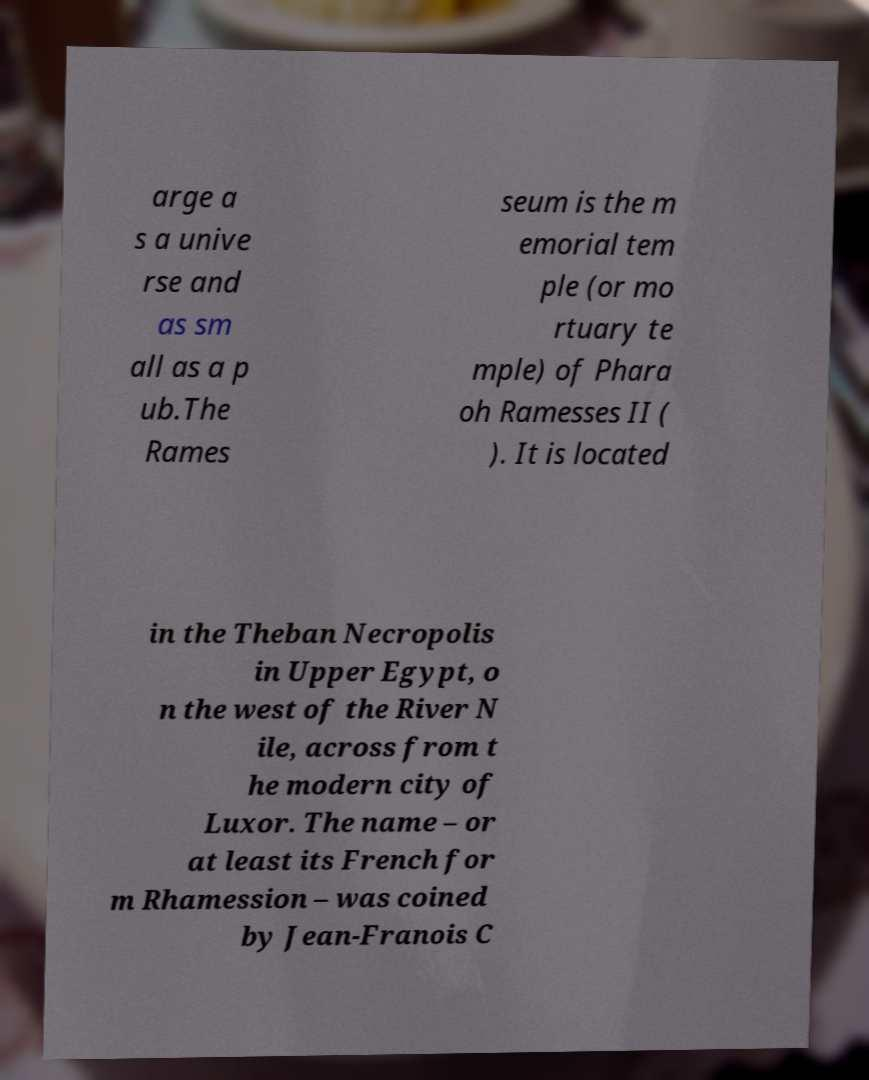There's text embedded in this image that I need extracted. Can you transcribe it verbatim? arge a s a unive rse and as sm all as a p ub.The Rames seum is the m emorial tem ple (or mo rtuary te mple) of Phara oh Ramesses II ( ). It is located in the Theban Necropolis in Upper Egypt, o n the west of the River N ile, across from t he modern city of Luxor. The name – or at least its French for m Rhamession – was coined by Jean-Franois C 